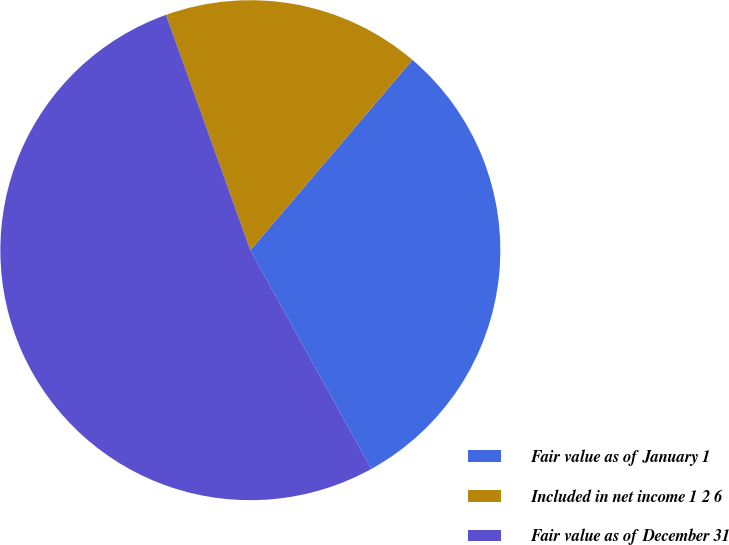Convert chart to OTSL. <chart><loc_0><loc_0><loc_500><loc_500><pie_chart><fcel>Fair value as of January 1<fcel>Included in net income 1 2 6<fcel>Fair value as of December 31<nl><fcel>30.73%<fcel>16.71%<fcel>52.56%<nl></chart> 